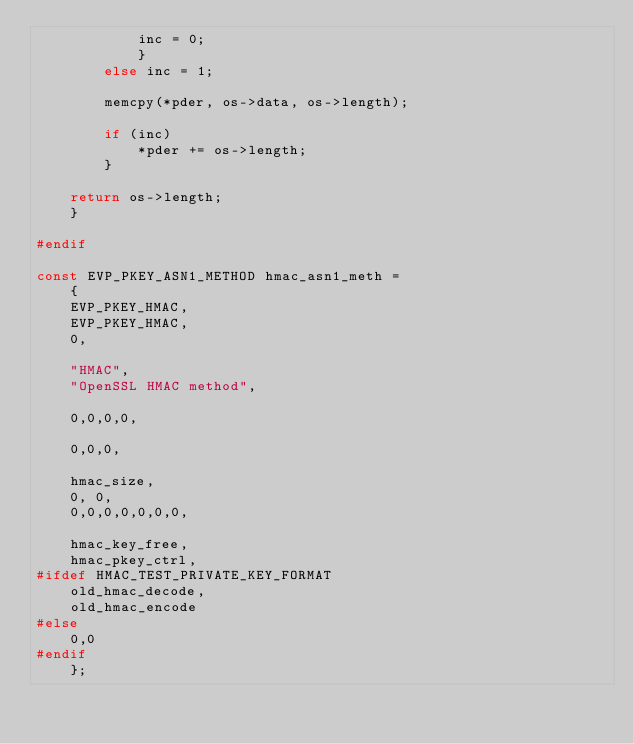Convert code to text. <code><loc_0><loc_0><loc_500><loc_500><_C_>			inc = 0;
			}
		else inc = 1;

		memcpy(*pder, os->data, os->length);

		if (inc)
			*pder += os->length;
		}
			
	return os->length;
	}

#endif

const EVP_PKEY_ASN1_METHOD hmac_asn1_meth = 
	{
	EVP_PKEY_HMAC,
	EVP_PKEY_HMAC,
	0,

	"HMAC",
	"OpenSSL HMAC method",

	0,0,0,0,

	0,0,0,

	hmac_size,
	0, 0,
	0,0,0,0,0,0,0,

	hmac_key_free,
	hmac_pkey_ctrl,
#ifdef HMAC_TEST_PRIVATE_KEY_FORMAT
	old_hmac_decode,
	old_hmac_encode
#else
	0,0
#endif
	};

</code> 